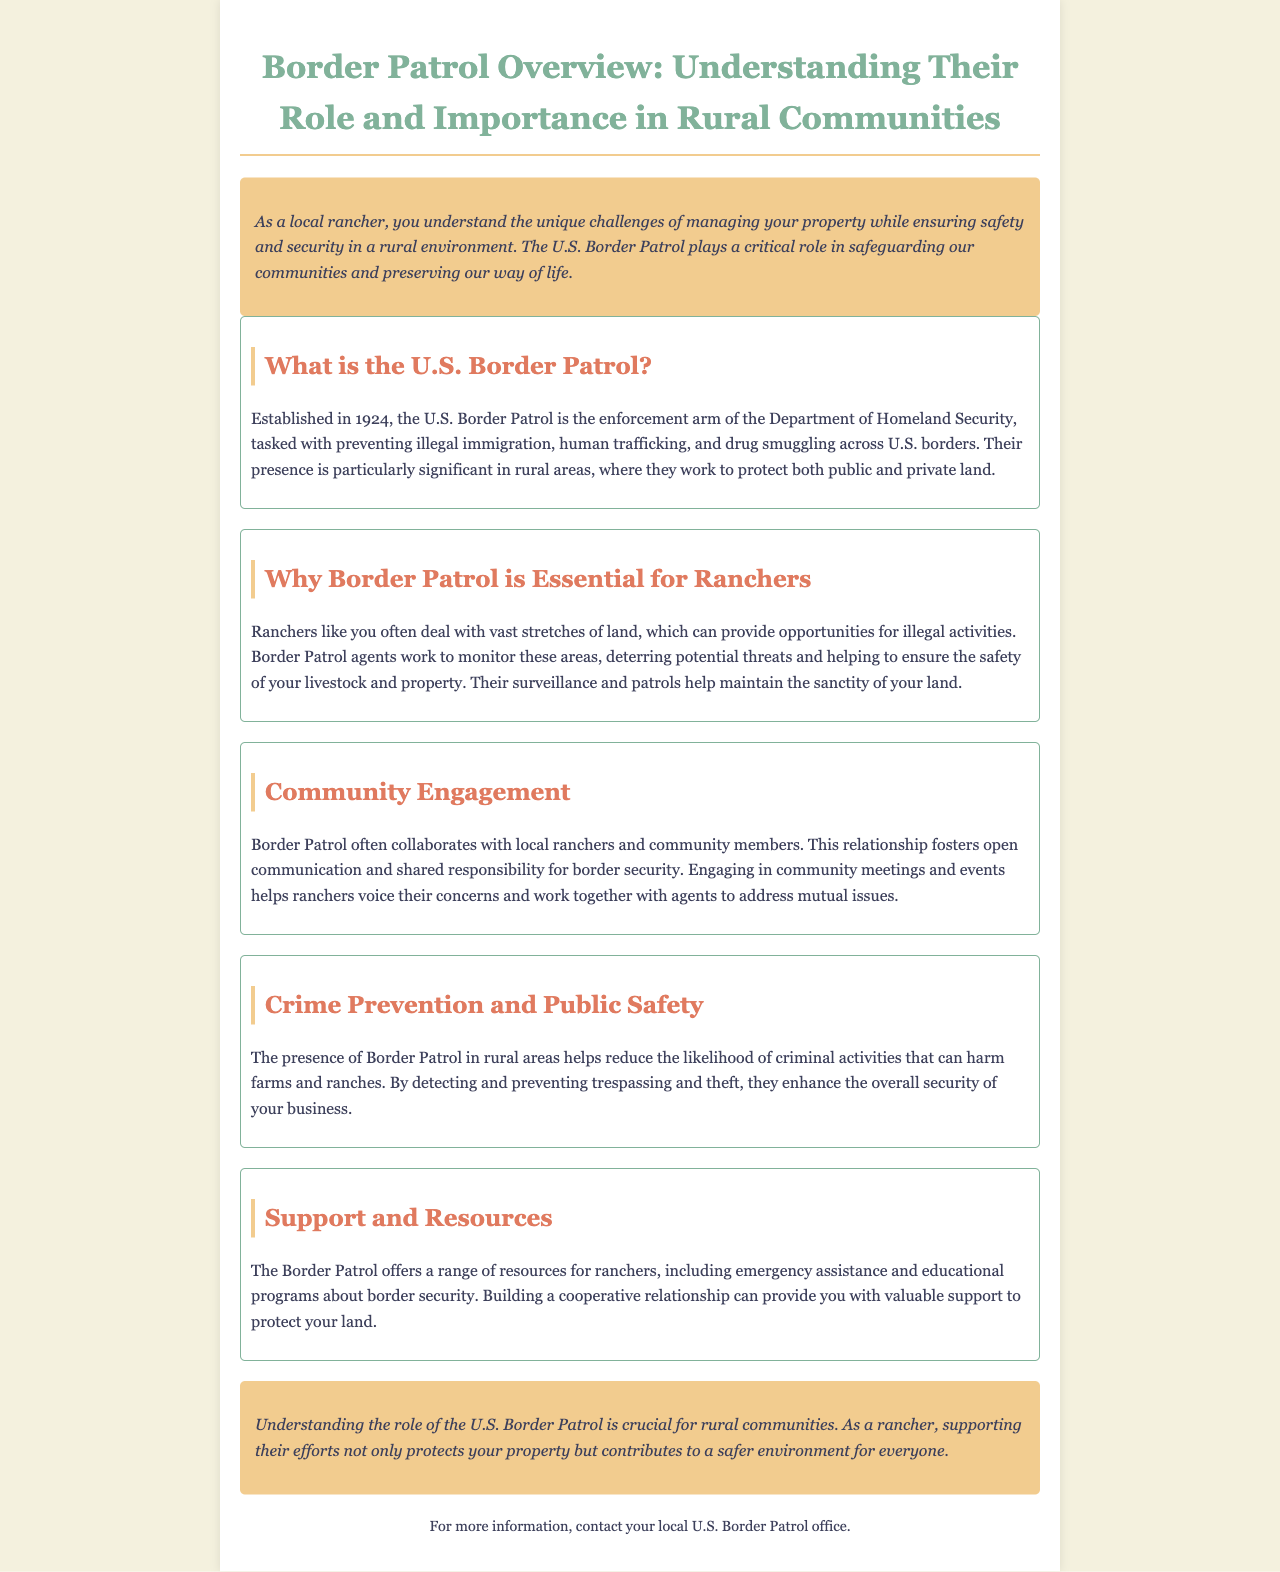What is the purpose of the U.S. Border Patrol? The purpose of the U.S. Border Patrol is to prevent illegal immigration, human trafficking, and drug smuggling across U.S. borders.
Answer: prevent illegal immigration, human trafficking, and drug smuggling When was the U.S. Border Patrol established? The establishment year of the U.S. Border Patrol is mentioned in the document.
Answer: 1924 How does Border Patrol support ranchers? The document details how Border Patrol agents deter potential threats and ensure the safety of livestock and property, offering various support resources.
Answer: deter potential threats and ensure the safety What role does community engagement play? The document explains that community engagement fosters open communication and shared responsibility for border security between Border Patrol and ranchers.
Answer: fosters open communication and shared responsibility What is a benefit of Border Patrol's presence in rural areas? The document highlights that their presence reduces the likelihood of criminal activities that can harm farms and ranches.
Answer: reduces the likelihood of criminal activities What type of assistance does Border Patrol provide? The document describes emergency assistance and educational programs provided by Border Patrol to ranchers.
Answer: emergency assistance and educational programs 